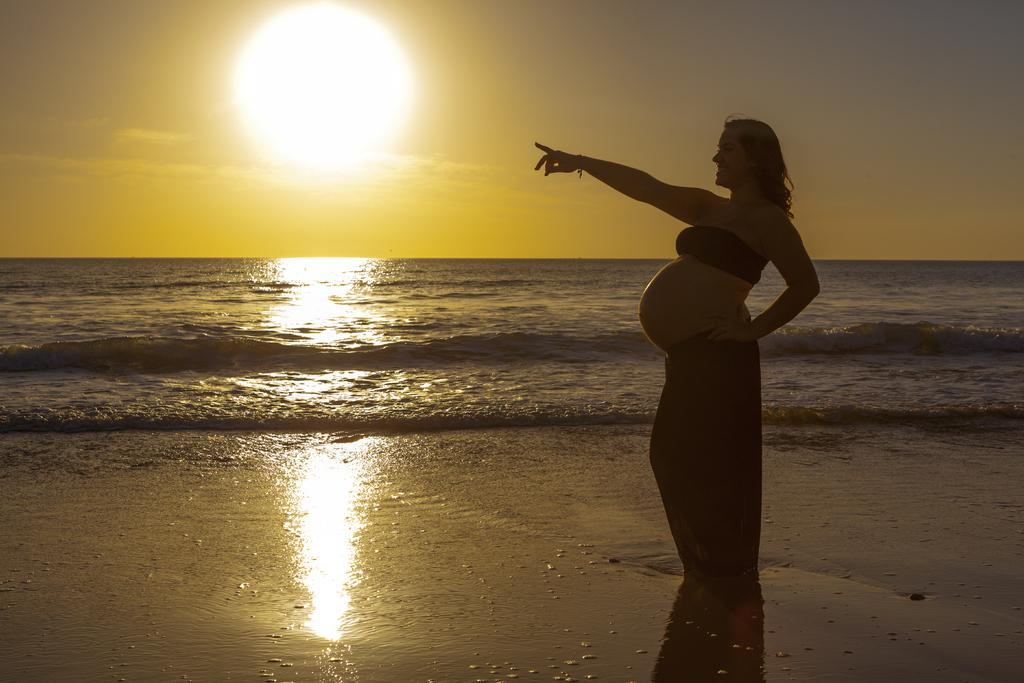Describe this image in one or two sentences. This image is taken outdoors. At the top of the image there is the sky with clouds and sun. At the bottom of the image there is water. In the middle of the image there is a sea with waves. In the middle of the image a pregnant lady is standing on the ground. 